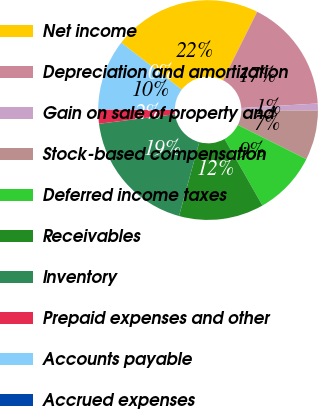<chart> <loc_0><loc_0><loc_500><loc_500><pie_chart><fcel>Net income<fcel>Depreciation and amortization<fcel>Gain on sale of property and<fcel>Stock-based compensation<fcel>Deferred income taxes<fcel>Receivables<fcel>Inventory<fcel>Prepaid expenses and other<fcel>Accounts payable<fcel>Accrued expenses<nl><fcel>21.87%<fcel>16.67%<fcel>1.04%<fcel>7.29%<fcel>9.38%<fcel>12.5%<fcel>18.75%<fcel>2.08%<fcel>10.42%<fcel>0.0%<nl></chart> 